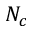Convert formula to latex. <formula><loc_0><loc_0><loc_500><loc_500>N _ { c }</formula> 